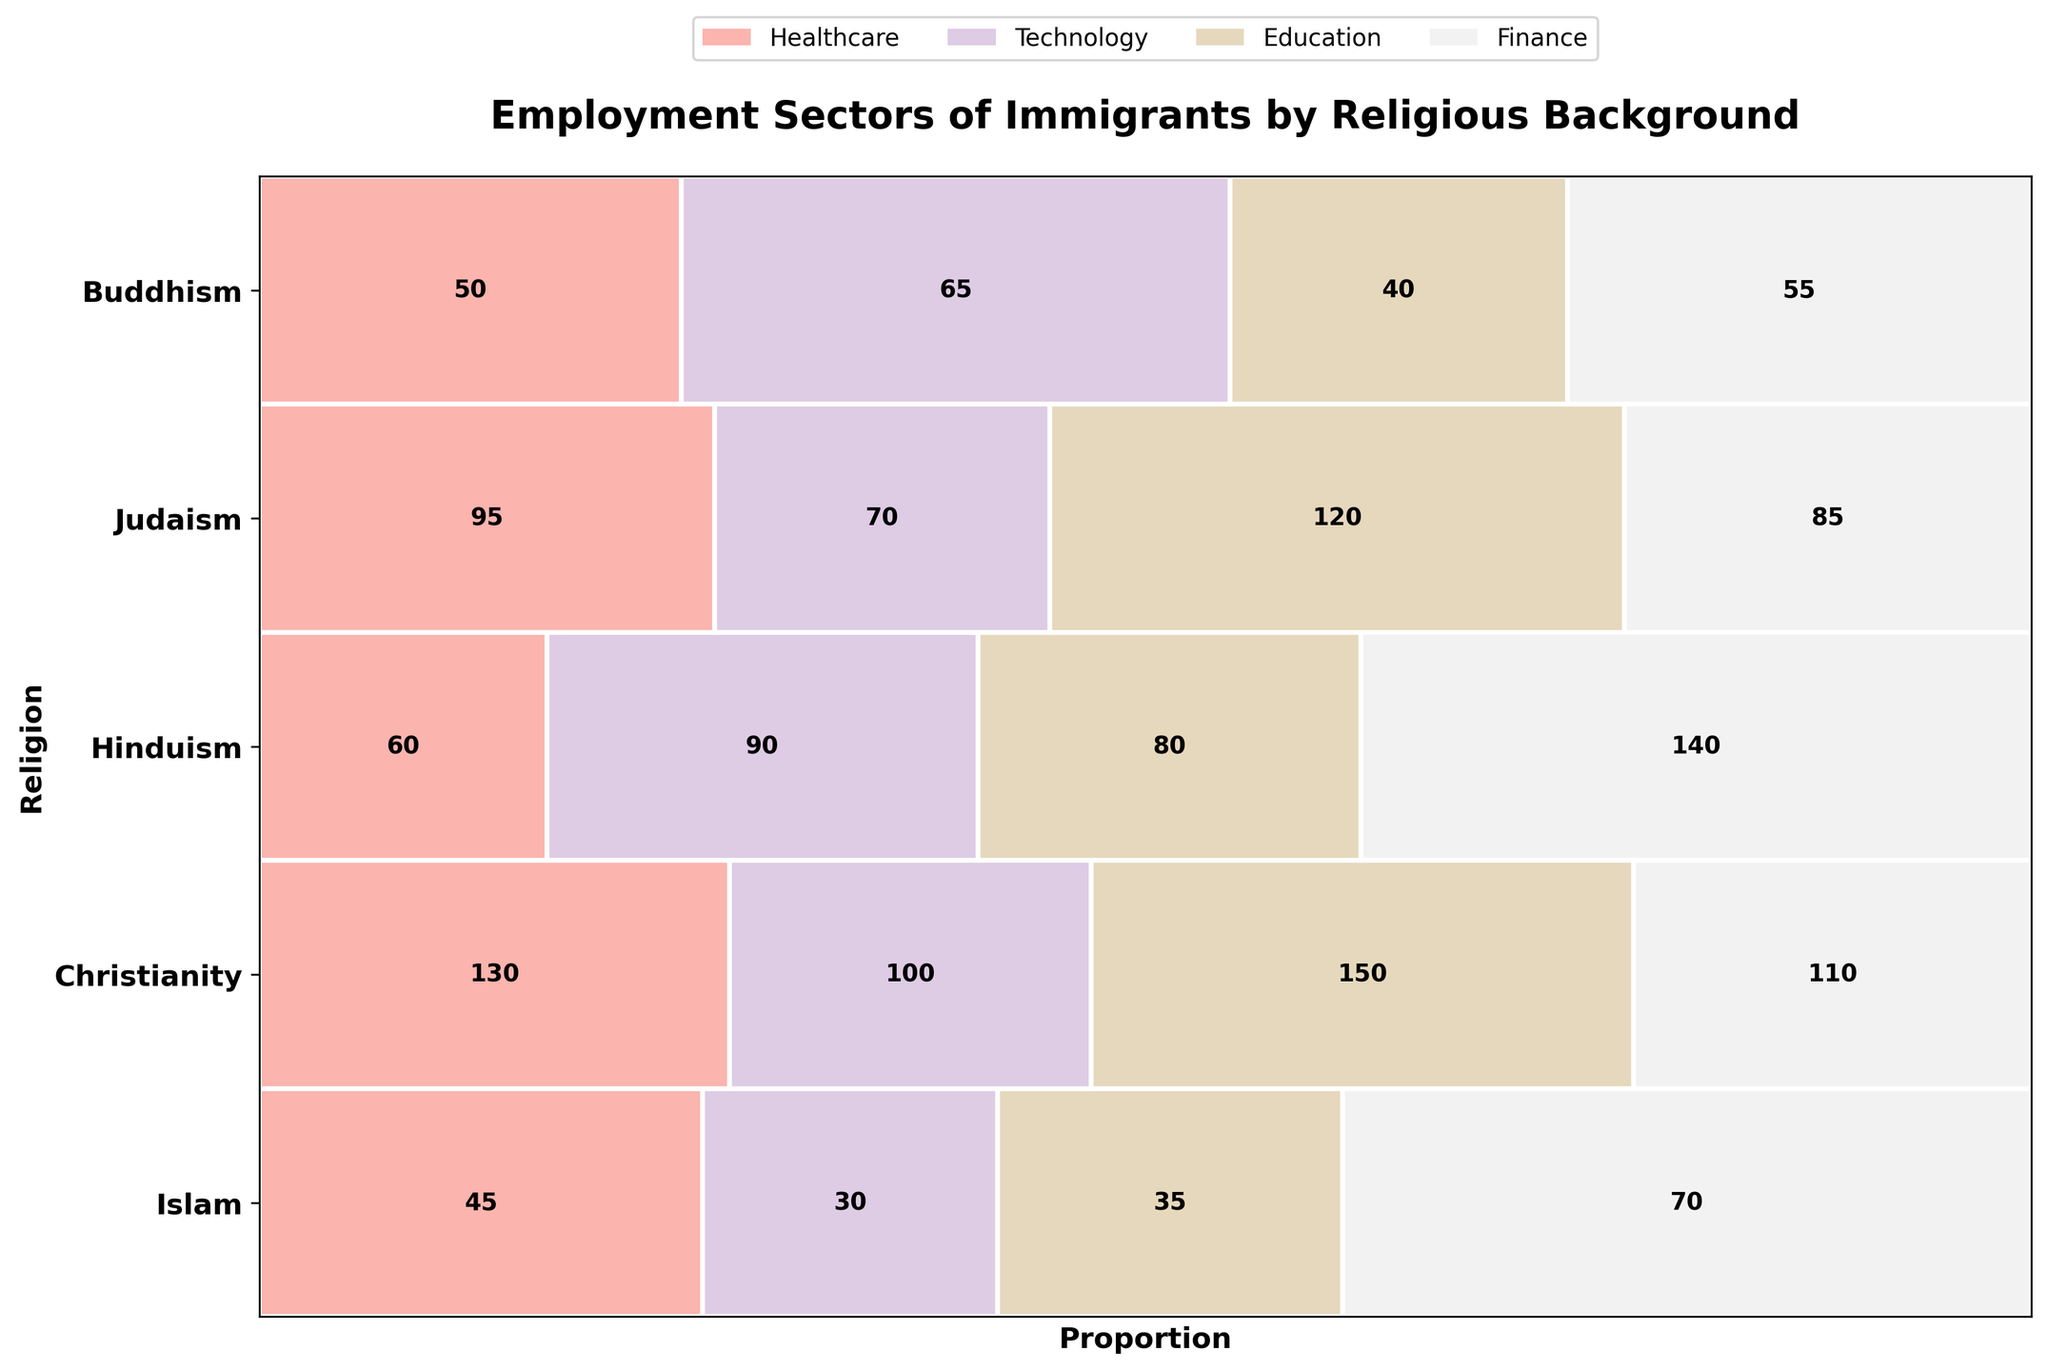What is the title of the plot? The title of the plot is located at the top and is generally bold and larger in size compared to other text elements. Reading this text gives us the title.
Answer: Employment Sectors of Immigrants by Religious Background Which religious group is most represented in the Healthcare sector? By identifying the height of the rectangles under the Healthcare sector and noting the corresponding y-axis label, we can determine which religious group has the highest count in the Healthcare sector.
Answer: Christianity Which employment sector has the smallest representation among immigrants from Buddhism? We evaluate the widths of the rectangles across different sectors for Buddhism on the y-axis. The smallest width reveals the sector with the least representation.
Answer: Finance How many immigrants from the Hinduism background are employed in the Technology sector? The figure might contain numeric labels within rectangles. By locating the rectangle for Hinduism at the intersection with Technology and reading any numeric label inside it, we get the count.
Answer: 140 What is the total number of immigrants from Judaism in Healthcare and Technology combined? First, locate the rectangles for Judaism under Healthcare and Technology, sum their values from the labels within the rectangles.
Answer: 95 Compare the representation between Islam and Christianity in the Finance sector. Which one is higher, and by how much? Locate the Finance sector rectangles for Islam and Christianity on the respective y-axis positions, read the values in them, then subtract the smaller value from the larger one to find the difference.
Answer: Christianity is higher by 30 Which sector seems to have the highest diversity of religious backgrounds based on the mosaic plot? The most diverse sector will have rectangles from the most religious groups in it. Visual inspection of the number of distinct colored rectangles in each sector indicates this.
Answer: Healthcare What is the sum of immigrants from Hinduism background across all employment sectors? Sum the values from all rectangles for Hinduism across all sectors. These values are visually labeled within the rectangles.
Answer: 370 How does the representation of immigrants from Judaism in Education compare to those in Finance? Compare the widths or numeric values of the rectangles for Judaism in the Education and Finance sectors.
Answer: They are nearly equal, with Education having 50 and Finance 65 Looking at the plot, which employment sector is most prevalent among immigrants from Islam? Identify the widest rectangle for Islam across all sectors. The sector corresponding to this rectangle is the most prevalent.
Answer: Healthcare 